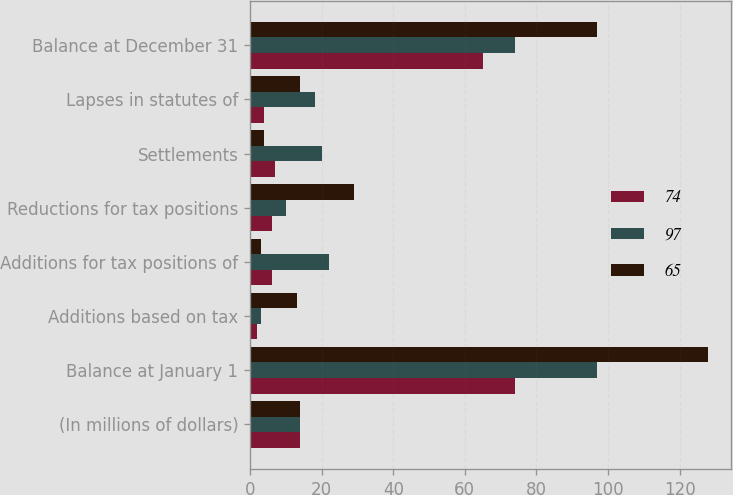<chart> <loc_0><loc_0><loc_500><loc_500><stacked_bar_chart><ecel><fcel>(In millions of dollars)<fcel>Balance at January 1<fcel>Additions based on tax<fcel>Additions for tax positions of<fcel>Reductions for tax positions<fcel>Settlements<fcel>Lapses in statutes of<fcel>Balance at December 31<nl><fcel>74<fcel>14<fcel>74<fcel>2<fcel>6<fcel>6<fcel>7<fcel>4<fcel>65<nl><fcel>97<fcel>14<fcel>97<fcel>3<fcel>22<fcel>10<fcel>20<fcel>18<fcel>74<nl><fcel>65<fcel>14<fcel>128<fcel>13<fcel>3<fcel>29<fcel>4<fcel>14<fcel>97<nl></chart> 